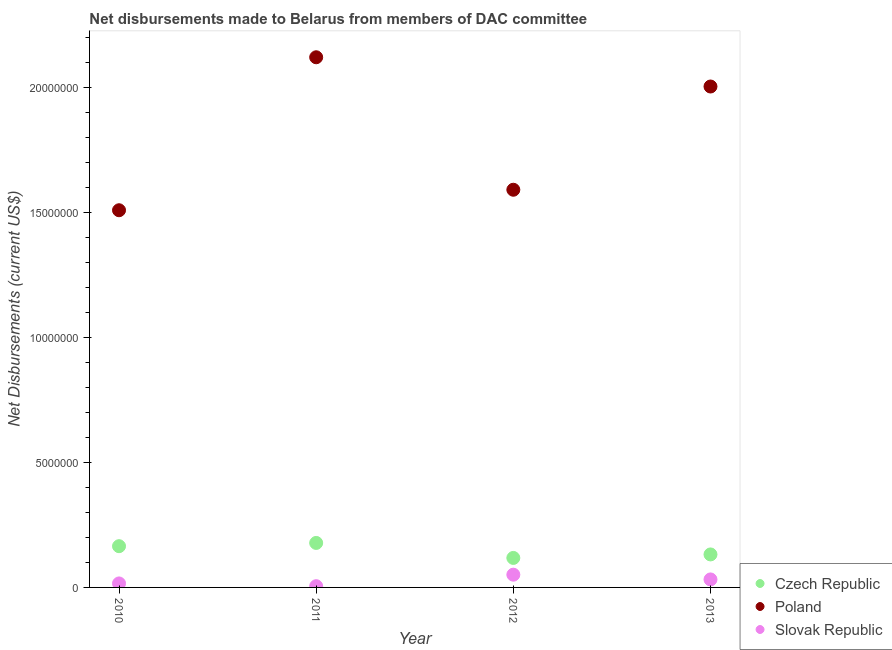Is the number of dotlines equal to the number of legend labels?
Your answer should be very brief. Yes. What is the net disbursements made by slovak republic in 2012?
Make the answer very short. 5.10e+05. Across all years, what is the maximum net disbursements made by czech republic?
Keep it short and to the point. 1.78e+06. Across all years, what is the minimum net disbursements made by slovak republic?
Offer a terse response. 5.00e+04. In which year was the net disbursements made by slovak republic minimum?
Your answer should be compact. 2011. What is the total net disbursements made by czech republic in the graph?
Ensure brevity in your answer.  5.93e+06. What is the difference between the net disbursements made by slovak republic in 2011 and that in 2012?
Your answer should be very brief. -4.60e+05. What is the difference between the net disbursements made by slovak republic in 2010 and the net disbursements made by poland in 2012?
Offer a very short reply. -1.58e+07. What is the average net disbursements made by czech republic per year?
Give a very brief answer. 1.48e+06. In the year 2010, what is the difference between the net disbursements made by poland and net disbursements made by czech republic?
Give a very brief answer. 1.34e+07. What is the ratio of the net disbursements made by poland in 2012 to that in 2013?
Provide a short and direct response. 0.79. What is the difference between the highest and the second highest net disbursements made by slovak republic?
Your answer should be very brief. 1.90e+05. What is the difference between the highest and the lowest net disbursements made by slovak republic?
Ensure brevity in your answer.  4.60e+05. In how many years, is the net disbursements made by czech republic greater than the average net disbursements made by czech republic taken over all years?
Offer a very short reply. 2. Is it the case that in every year, the sum of the net disbursements made by czech republic and net disbursements made by poland is greater than the net disbursements made by slovak republic?
Offer a terse response. Yes. Is the net disbursements made by poland strictly greater than the net disbursements made by slovak republic over the years?
Ensure brevity in your answer.  Yes. Does the graph contain any zero values?
Offer a terse response. No. How are the legend labels stacked?
Your response must be concise. Vertical. What is the title of the graph?
Your answer should be very brief. Net disbursements made to Belarus from members of DAC committee. Does "Profit Tax" appear as one of the legend labels in the graph?
Keep it short and to the point. No. What is the label or title of the X-axis?
Provide a short and direct response. Year. What is the label or title of the Y-axis?
Keep it short and to the point. Net Disbursements (current US$). What is the Net Disbursements (current US$) in Czech Republic in 2010?
Make the answer very short. 1.65e+06. What is the Net Disbursements (current US$) in Poland in 2010?
Offer a terse response. 1.51e+07. What is the Net Disbursements (current US$) of Czech Republic in 2011?
Offer a very short reply. 1.78e+06. What is the Net Disbursements (current US$) in Poland in 2011?
Your answer should be very brief. 2.12e+07. What is the Net Disbursements (current US$) of Slovak Republic in 2011?
Keep it short and to the point. 5.00e+04. What is the Net Disbursements (current US$) of Czech Republic in 2012?
Give a very brief answer. 1.18e+06. What is the Net Disbursements (current US$) in Poland in 2012?
Your answer should be compact. 1.59e+07. What is the Net Disbursements (current US$) of Slovak Republic in 2012?
Ensure brevity in your answer.  5.10e+05. What is the Net Disbursements (current US$) in Czech Republic in 2013?
Your response must be concise. 1.32e+06. What is the Net Disbursements (current US$) of Poland in 2013?
Make the answer very short. 2.00e+07. What is the Net Disbursements (current US$) in Slovak Republic in 2013?
Ensure brevity in your answer.  3.20e+05. Across all years, what is the maximum Net Disbursements (current US$) in Czech Republic?
Give a very brief answer. 1.78e+06. Across all years, what is the maximum Net Disbursements (current US$) in Poland?
Provide a short and direct response. 2.12e+07. Across all years, what is the maximum Net Disbursements (current US$) in Slovak Republic?
Make the answer very short. 5.10e+05. Across all years, what is the minimum Net Disbursements (current US$) of Czech Republic?
Keep it short and to the point. 1.18e+06. Across all years, what is the minimum Net Disbursements (current US$) of Poland?
Your response must be concise. 1.51e+07. Across all years, what is the minimum Net Disbursements (current US$) in Slovak Republic?
Your answer should be compact. 5.00e+04. What is the total Net Disbursements (current US$) of Czech Republic in the graph?
Make the answer very short. 5.93e+06. What is the total Net Disbursements (current US$) of Poland in the graph?
Offer a very short reply. 7.22e+07. What is the total Net Disbursements (current US$) of Slovak Republic in the graph?
Your response must be concise. 1.04e+06. What is the difference between the Net Disbursements (current US$) in Czech Republic in 2010 and that in 2011?
Your response must be concise. -1.30e+05. What is the difference between the Net Disbursements (current US$) of Poland in 2010 and that in 2011?
Provide a short and direct response. -6.12e+06. What is the difference between the Net Disbursements (current US$) of Czech Republic in 2010 and that in 2012?
Provide a succinct answer. 4.70e+05. What is the difference between the Net Disbursements (current US$) in Poland in 2010 and that in 2012?
Ensure brevity in your answer.  -8.20e+05. What is the difference between the Net Disbursements (current US$) of Slovak Republic in 2010 and that in 2012?
Offer a very short reply. -3.50e+05. What is the difference between the Net Disbursements (current US$) of Czech Republic in 2010 and that in 2013?
Offer a terse response. 3.30e+05. What is the difference between the Net Disbursements (current US$) of Poland in 2010 and that in 2013?
Your response must be concise. -4.95e+06. What is the difference between the Net Disbursements (current US$) in Slovak Republic in 2010 and that in 2013?
Ensure brevity in your answer.  -1.60e+05. What is the difference between the Net Disbursements (current US$) of Poland in 2011 and that in 2012?
Offer a very short reply. 5.30e+06. What is the difference between the Net Disbursements (current US$) in Slovak Republic in 2011 and that in 2012?
Ensure brevity in your answer.  -4.60e+05. What is the difference between the Net Disbursements (current US$) in Czech Republic in 2011 and that in 2013?
Provide a succinct answer. 4.60e+05. What is the difference between the Net Disbursements (current US$) in Poland in 2011 and that in 2013?
Your answer should be very brief. 1.17e+06. What is the difference between the Net Disbursements (current US$) of Slovak Republic in 2011 and that in 2013?
Provide a short and direct response. -2.70e+05. What is the difference between the Net Disbursements (current US$) of Czech Republic in 2012 and that in 2013?
Offer a terse response. -1.40e+05. What is the difference between the Net Disbursements (current US$) of Poland in 2012 and that in 2013?
Ensure brevity in your answer.  -4.13e+06. What is the difference between the Net Disbursements (current US$) in Czech Republic in 2010 and the Net Disbursements (current US$) in Poland in 2011?
Make the answer very short. -1.96e+07. What is the difference between the Net Disbursements (current US$) of Czech Republic in 2010 and the Net Disbursements (current US$) of Slovak Republic in 2011?
Give a very brief answer. 1.60e+06. What is the difference between the Net Disbursements (current US$) in Poland in 2010 and the Net Disbursements (current US$) in Slovak Republic in 2011?
Offer a very short reply. 1.50e+07. What is the difference between the Net Disbursements (current US$) in Czech Republic in 2010 and the Net Disbursements (current US$) in Poland in 2012?
Ensure brevity in your answer.  -1.43e+07. What is the difference between the Net Disbursements (current US$) in Czech Republic in 2010 and the Net Disbursements (current US$) in Slovak Republic in 2012?
Give a very brief answer. 1.14e+06. What is the difference between the Net Disbursements (current US$) in Poland in 2010 and the Net Disbursements (current US$) in Slovak Republic in 2012?
Keep it short and to the point. 1.46e+07. What is the difference between the Net Disbursements (current US$) in Czech Republic in 2010 and the Net Disbursements (current US$) in Poland in 2013?
Your response must be concise. -1.84e+07. What is the difference between the Net Disbursements (current US$) in Czech Republic in 2010 and the Net Disbursements (current US$) in Slovak Republic in 2013?
Your answer should be compact. 1.33e+06. What is the difference between the Net Disbursements (current US$) of Poland in 2010 and the Net Disbursements (current US$) of Slovak Republic in 2013?
Keep it short and to the point. 1.48e+07. What is the difference between the Net Disbursements (current US$) of Czech Republic in 2011 and the Net Disbursements (current US$) of Poland in 2012?
Give a very brief answer. -1.41e+07. What is the difference between the Net Disbursements (current US$) in Czech Republic in 2011 and the Net Disbursements (current US$) in Slovak Republic in 2012?
Make the answer very short. 1.27e+06. What is the difference between the Net Disbursements (current US$) of Poland in 2011 and the Net Disbursements (current US$) of Slovak Republic in 2012?
Your answer should be very brief. 2.07e+07. What is the difference between the Net Disbursements (current US$) in Czech Republic in 2011 and the Net Disbursements (current US$) in Poland in 2013?
Provide a succinct answer. -1.83e+07. What is the difference between the Net Disbursements (current US$) of Czech Republic in 2011 and the Net Disbursements (current US$) of Slovak Republic in 2013?
Provide a short and direct response. 1.46e+06. What is the difference between the Net Disbursements (current US$) of Poland in 2011 and the Net Disbursements (current US$) of Slovak Republic in 2013?
Your response must be concise. 2.09e+07. What is the difference between the Net Disbursements (current US$) in Czech Republic in 2012 and the Net Disbursements (current US$) in Poland in 2013?
Your response must be concise. -1.89e+07. What is the difference between the Net Disbursements (current US$) in Czech Republic in 2012 and the Net Disbursements (current US$) in Slovak Republic in 2013?
Your answer should be very brief. 8.60e+05. What is the difference between the Net Disbursements (current US$) in Poland in 2012 and the Net Disbursements (current US$) in Slovak Republic in 2013?
Your answer should be very brief. 1.56e+07. What is the average Net Disbursements (current US$) of Czech Republic per year?
Make the answer very short. 1.48e+06. What is the average Net Disbursements (current US$) of Poland per year?
Offer a very short reply. 1.81e+07. What is the average Net Disbursements (current US$) in Slovak Republic per year?
Make the answer very short. 2.60e+05. In the year 2010, what is the difference between the Net Disbursements (current US$) in Czech Republic and Net Disbursements (current US$) in Poland?
Your answer should be compact. -1.34e+07. In the year 2010, what is the difference between the Net Disbursements (current US$) of Czech Republic and Net Disbursements (current US$) of Slovak Republic?
Provide a succinct answer. 1.49e+06. In the year 2010, what is the difference between the Net Disbursements (current US$) of Poland and Net Disbursements (current US$) of Slovak Republic?
Provide a succinct answer. 1.49e+07. In the year 2011, what is the difference between the Net Disbursements (current US$) in Czech Republic and Net Disbursements (current US$) in Poland?
Ensure brevity in your answer.  -1.94e+07. In the year 2011, what is the difference between the Net Disbursements (current US$) in Czech Republic and Net Disbursements (current US$) in Slovak Republic?
Offer a terse response. 1.73e+06. In the year 2011, what is the difference between the Net Disbursements (current US$) in Poland and Net Disbursements (current US$) in Slovak Republic?
Offer a terse response. 2.12e+07. In the year 2012, what is the difference between the Net Disbursements (current US$) of Czech Republic and Net Disbursements (current US$) of Poland?
Give a very brief answer. -1.47e+07. In the year 2012, what is the difference between the Net Disbursements (current US$) in Czech Republic and Net Disbursements (current US$) in Slovak Republic?
Your answer should be very brief. 6.70e+05. In the year 2012, what is the difference between the Net Disbursements (current US$) of Poland and Net Disbursements (current US$) of Slovak Republic?
Offer a terse response. 1.54e+07. In the year 2013, what is the difference between the Net Disbursements (current US$) of Czech Republic and Net Disbursements (current US$) of Poland?
Your response must be concise. -1.87e+07. In the year 2013, what is the difference between the Net Disbursements (current US$) in Poland and Net Disbursements (current US$) in Slovak Republic?
Offer a terse response. 1.97e+07. What is the ratio of the Net Disbursements (current US$) in Czech Republic in 2010 to that in 2011?
Provide a short and direct response. 0.93. What is the ratio of the Net Disbursements (current US$) of Poland in 2010 to that in 2011?
Provide a short and direct response. 0.71. What is the ratio of the Net Disbursements (current US$) in Slovak Republic in 2010 to that in 2011?
Give a very brief answer. 3.2. What is the ratio of the Net Disbursements (current US$) of Czech Republic in 2010 to that in 2012?
Your response must be concise. 1.4. What is the ratio of the Net Disbursements (current US$) in Poland in 2010 to that in 2012?
Make the answer very short. 0.95. What is the ratio of the Net Disbursements (current US$) of Slovak Republic in 2010 to that in 2012?
Your response must be concise. 0.31. What is the ratio of the Net Disbursements (current US$) of Poland in 2010 to that in 2013?
Give a very brief answer. 0.75. What is the ratio of the Net Disbursements (current US$) of Slovak Republic in 2010 to that in 2013?
Your response must be concise. 0.5. What is the ratio of the Net Disbursements (current US$) of Czech Republic in 2011 to that in 2012?
Your answer should be compact. 1.51. What is the ratio of the Net Disbursements (current US$) of Poland in 2011 to that in 2012?
Your response must be concise. 1.33. What is the ratio of the Net Disbursements (current US$) of Slovak Republic in 2011 to that in 2012?
Keep it short and to the point. 0.1. What is the ratio of the Net Disbursements (current US$) in Czech Republic in 2011 to that in 2013?
Offer a terse response. 1.35. What is the ratio of the Net Disbursements (current US$) in Poland in 2011 to that in 2013?
Give a very brief answer. 1.06. What is the ratio of the Net Disbursements (current US$) of Slovak Republic in 2011 to that in 2013?
Offer a terse response. 0.16. What is the ratio of the Net Disbursements (current US$) in Czech Republic in 2012 to that in 2013?
Give a very brief answer. 0.89. What is the ratio of the Net Disbursements (current US$) of Poland in 2012 to that in 2013?
Your answer should be very brief. 0.79. What is the ratio of the Net Disbursements (current US$) in Slovak Republic in 2012 to that in 2013?
Your answer should be compact. 1.59. What is the difference between the highest and the second highest Net Disbursements (current US$) in Poland?
Your response must be concise. 1.17e+06. What is the difference between the highest and the lowest Net Disbursements (current US$) of Czech Republic?
Ensure brevity in your answer.  6.00e+05. What is the difference between the highest and the lowest Net Disbursements (current US$) in Poland?
Offer a very short reply. 6.12e+06. What is the difference between the highest and the lowest Net Disbursements (current US$) in Slovak Republic?
Give a very brief answer. 4.60e+05. 